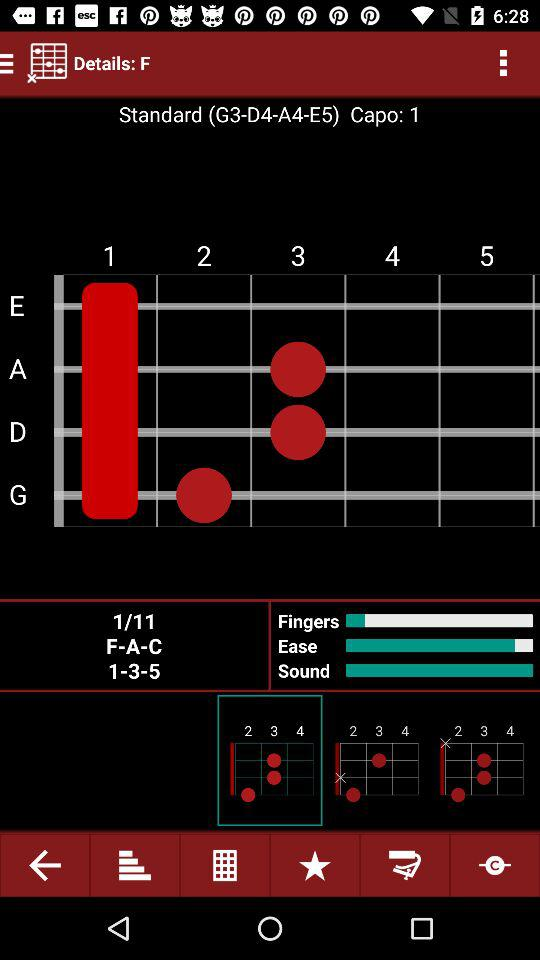What's the "Standard" sequence? The "Standard" sequence is G3-D4-A4-E5. 